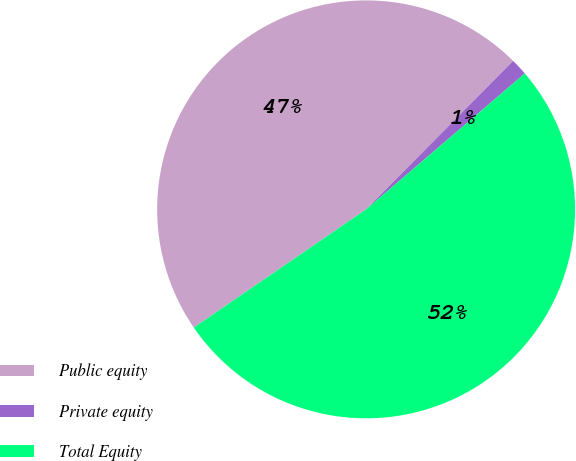<chart> <loc_0><loc_0><loc_500><loc_500><pie_chart><fcel>Public equity<fcel>Private equity<fcel>Total Equity<nl><fcel>47.0%<fcel>1.31%<fcel>51.7%<nl></chart> 